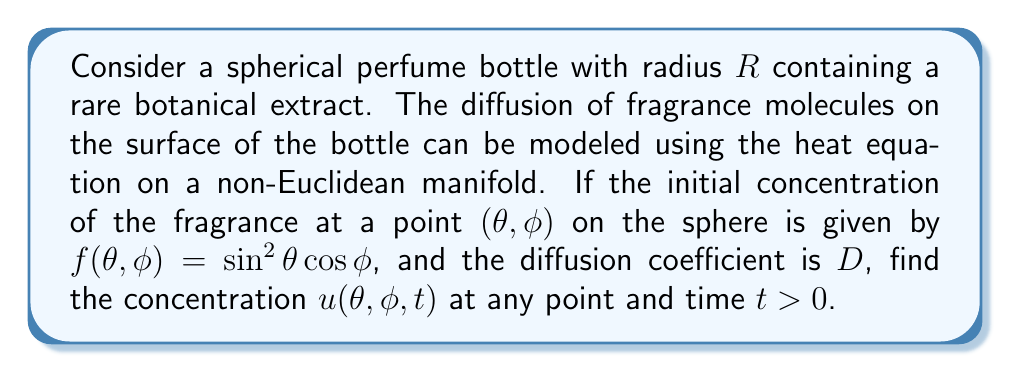Can you solve this math problem? 1) The heat equation on a sphere (non-Euclidean manifold) is given by:

   $$\frac{\partial u}{\partial t} = \frac{D}{R^2} \Delta_S u$$

   where $\Delta_S$ is the Laplace-Beltrami operator on a sphere.

2) The Laplace-Beltrami operator in spherical coordinates is:

   $$\Delta_S = \frac{1}{\sin\theta} \frac{\partial}{\partial \theta} \left(\sin\theta \frac{\partial}{\partial \theta}\right) + \frac{1}{\sin^2\theta} \frac{\partial^2}{\partial \phi^2}$$

3) The solution to the heat equation on a sphere can be expressed using spherical harmonics:

   $$u(\theta, \phi, t) = \sum_{l=0}^{\infty} \sum_{m=-l}^l c_{lm} Y_{lm}(\theta, \phi) e^{-l(l+1)Dt/R^2}$$

   where $Y_{lm}(\theta, \phi)$ are the spherical harmonics and $c_{lm}$ are coefficients.

4) The initial condition $f(\theta, \phi) = \sin^2\theta \cos\phi$ can be expressed in terms of spherical harmonics:

   $$f(\theta, \phi) = \sqrt{\frac{2\pi}{3}} Y_{1,1}(\theta, \phi) + \sqrt{\frac{2\pi}{3}} Y_{1,-1}(\theta, \phi) + \frac{2}{3}\sqrt{\frac{4\pi}{5}} Y_{2,0}(\theta, \phi)$$

5) Therefore, the solution is:

   $$u(\theta, \phi, t) = \left(\sqrt{\frac{2\pi}{3}} Y_{1,1}(\theta, \phi) + \sqrt{\frac{2\pi}{3}} Y_{1,-1}(\theta, \phi)\right) e^{-2Dt/R^2} + \frac{2}{3}\sqrt{\frac{4\pi}{5}} Y_{2,0}(\theta, \phi) e^{-6Dt/R^2}$$

6) Expressing this in terms of $\theta$ and $\phi$:

   $$u(\theta, \phi, t) = \sin^2\theta \cos\phi \left(\frac{1}{5}e^{-6Dt/R^2} + \frac{4}{5}e^{-2Dt/R^2}\right)$$
Answer: $u(\theta, \phi, t) = \sin^2\theta \cos\phi \left(\frac{1}{5}e^{-6Dt/R^2} + \frac{4}{5}e^{-2Dt/R^2}\right)$ 